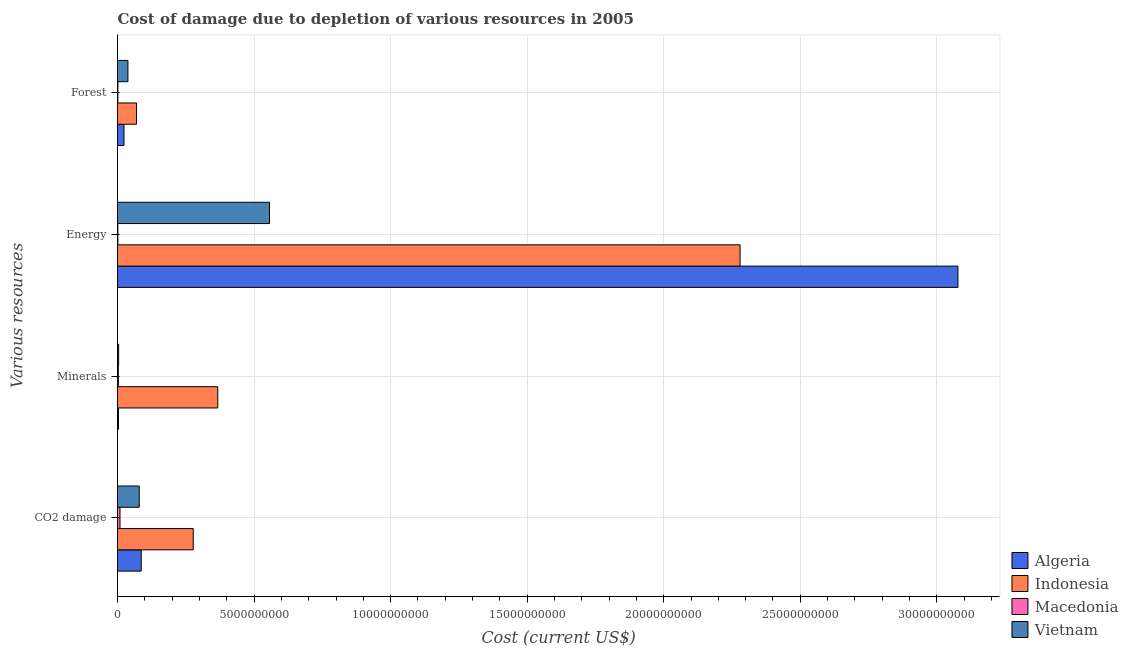How many different coloured bars are there?
Offer a very short reply. 4. How many bars are there on the 3rd tick from the top?
Your answer should be very brief. 4. What is the label of the 1st group of bars from the top?
Your response must be concise. Forest. What is the cost of damage due to depletion of coal in Macedonia?
Keep it short and to the point. 9.14e+07. Across all countries, what is the maximum cost of damage due to depletion of minerals?
Keep it short and to the point. 3.67e+09. Across all countries, what is the minimum cost of damage due to depletion of minerals?
Make the answer very short. 3.05e+07. In which country was the cost of damage due to depletion of energy maximum?
Make the answer very short. Algeria. In which country was the cost of damage due to depletion of forests minimum?
Keep it short and to the point. Macedonia. What is the total cost of damage due to depletion of forests in the graph?
Offer a very short reply. 1.33e+09. What is the difference between the cost of damage due to depletion of minerals in Macedonia and that in Vietnam?
Provide a succinct answer. -1.06e+07. What is the difference between the cost of damage due to depletion of coal in Algeria and the cost of damage due to depletion of energy in Vietnam?
Offer a terse response. -4.70e+09. What is the average cost of damage due to depletion of forests per country?
Ensure brevity in your answer.  3.32e+08. What is the difference between the cost of damage due to depletion of forests and cost of damage due to depletion of coal in Algeria?
Make the answer very short. -6.31e+08. In how many countries, is the cost of damage due to depletion of minerals greater than 9000000000 US$?
Ensure brevity in your answer.  0. What is the ratio of the cost of damage due to depletion of energy in Indonesia to that in Algeria?
Provide a short and direct response. 0.74. What is the difference between the highest and the second highest cost of damage due to depletion of minerals?
Your response must be concise. 3.63e+09. What is the difference between the highest and the lowest cost of damage due to depletion of coal?
Your response must be concise. 2.68e+09. Is the sum of the cost of damage due to depletion of minerals in Macedonia and Algeria greater than the maximum cost of damage due to depletion of energy across all countries?
Your response must be concise. No. Is it the case that in every country, the sum of the cost of damage due to depletion of minerals and cost of damage due to depletion of forests is greater than the sum of cost of damage due to depletion of coal and cost of damage due to depletion of energy?
Offer a very short reply. No. What does the 2nd bar from the top in Energy represents?
Give a very brief answer. Macedonia. What does the 3rd bar from the bottom in Forest represents?
Your response must be concise. Macedonia. Is it the case that in every country, the sum of the cost of damage due to depletion of coal and cost of damage due to depletion of minerals is greater than the cost of damage due to depletion of energy?
Provide a short and direct response. No. Are all the bars in the graph horizontal?
Offer a terse response. Yes. How many countries are there in the graph?
Keep it short and to the point. 4. Are the values on the major ticks of X-axis written in scientific E-notation?
Ensure brevity in your answer.  No. Does the graph contain any zero values?
Offer a terse response. No. Does the graph contain grids?
Ensure brevity in your answer.  Yes. How are the legend labels stacked?
Your answer should be very brief. Vertical. What is the title of the graph?
Your response must be concise. Cost of damage due to depletion of various resources in 2005 . Does "Lesotho" appear as one of the legend labels in the graph?
Your answer should be very brief. No. What is the label or title of the X-axis?
Your answer should be compact. Cost (current US$). What is the label or title of the Y-axis?
Your answer should be compact. Various resources. What is the Cost (current US$) in Algeria in CO2 damage?
Make the answer very short. 8.68e+08. What is the Cost (current US$) in Indonesia in CO2 damage?
Keep it short and to the point. 2.77e+09. What is the Cost (current US$) of Macedonia in CO2 damage?
Provide a short and direct response. 9.14e+07. What is the Cost (current US$) of Vietnam in CO2 damage?
Provide a short and direct response. 7.96e+08. What is the Cost (current US$) of Algeria in Minerals?
Offer a terse response. 3.52e+07. What is the Cost (current US$) in Indonesia in Minerals?
Your response must be concise. 3.67e+09. What is the Cost (current US$) in Macedonia in Minerals?
Keep it short and to the point. 3.05e+07. What is the Cost (current US$) of Vietnam in Minerals?
Your response must be concise. 4.10e+07. What is the Cost (current US$) of Algeria in Energy?
Provide a succinct answer. 3.08e+1. What is the Cost (current US$) of Indonesia in Energy?
Make the answer very short. 2.28e+1. What is the Cost (current US$) of Macedonia in Energy?
Your response must be concise. 1.33e+07. What is the Cost (current US$) in Vietnam in Energy?
Make the answer very short. 5.57e+09. What is the Cost (current US$) of Algeria in Forest?
Give a very brief answer. 2.37e+08. What is the Cost (current US$) of Indonesia in Forest?
Ensure brevity in your answer.  6.95e+08. What is the Cost (current US$) of Macedonia in Forest?
Provide a succinct answer. 1.38e+07. What is the Cost (current US$) of Vietnam in Forest?
Provide a succinct answer. 3.81e+08. Across all Various resources, what is the maximum Cost (current US$) in Algeria?
Give a very brief answer. 3.08e+1. Across all Various resources, what is the maximum Cost (current US$) in Indonesia?
Give a very brief answer. 2.28e+1. Across all Various resources, what is the maximum Cost (current US$) of Macedonia?
Provide a succinct answer. 9.14e+07. Across all Various resources, what is the maximum Cost (current US$) in Vietnam?
Offer a very short reply. 5.57e+09. Across all Various resources, what is the minimum Cost (current US$) of Algeria?
Your response must be concise. 3.52e+07. Across all Various resources, what is the minimum Cost (current US$) of Indonesia?
Ensure brevity in your answer.  6.95e+08. Across all Various resources, what is the minimum Cost (current US$) of Macedonia?
Keep it short and to the point. 1.33e+07. Across all Various resources, what is the minimum Cost (current US$) of Vietnam?
Offer a very short reply. 4.10e+07. What is the total Cost (current US$) of Algeria in the graph?
Provide a short and direct response. 3.19e+1. What is the total Cost (current US$) of Indonesia in the graph?
Offer a very short reply. 2.99e+1. What is the total Cost (current US$) of Macedonia in the graph?
Your answer should be compact. 1.49e+08. What is the total Cost (current US$) in Vietnam in the graph?
Your response must be concise. 6.78e+09. What is the difference between the Cost (current US$) of Algeria in CO2 damage and that in Minerals?
Your response must be concise. 8.33e+08. What is the difference between the Cost (current US$) in Indonesia in CO2 damage and that in Minerals?
Offer a very short reply. -8.98e+08. What is the difference between the Cost (current US$) in Macedonia in CO2 damage and that in Minerals?
Give a very brief answer. 6.10e+07. What is the difference between the Cost (current US$) in Vietnam in CO2 damage and that in Minerals?
Keep it short and to the point. 7.54e+08. What is the difference between the Cost (current US$) of Algeria in CO2 damage and that in Energy?
Give a very brief answer. -2.99e+1. What is the difference between the Cost (current US$) of Indonesia in CO2 damage and that in Energy?
Ensure brevity in your answer.  -2.00e+1. What is the difference between the Cost (current US$) in Macedonia in CO2 damage and that in Energy?
Keep it short and to the point. 7.81e+07. What is the difference between the Cost (current US$) in Vietnam in CO2 damage and that in Energy?
Give a very brief answer. -4.77e+09. What is the difference between the Cost (current US$) of Algeria in CO2 damage and that in Forest?
Your response must be concise. 6.31e+08. What is the difference between the Cost (current US$) of Indonesia in CO2 damage and that in Forest?
Your response must be concise. 2.08e+09. What is the difference between the Cost (current US$) in Macedonia in CO2 damage and that in Forest?
Your answer should be compact. 7.76e+07. What is the difference between the Cost (current US$) in Vietnam in CO2 damage and that in Forest?
Provide a succinct answer. 4.14e+08. What is the difference between the Cost (current US$) in Algeria in Minerals and that in Energy?
Ensure brevity in your answer.  -3.07e+1. What is the difference between the Cost (current US$) of Indonesia in Minerals and that in Energy?
Give a very brief answer. -1.91e+1. What is the difference between the Cost (current US$) of Macedonia in Minerals and that in Energy?
Keep it short and to the point. 1.71e+07. What is the difference between the Cost (current US$) in Vietnam in Minerals and that in Energy?
Ensure brevity in your answer.  -5.52e+09. What is the difference between the Cost (current US$) in Algeria in Minerals and that in Forest?
Provide a short and direct response. -2.02e+08. What is the difference between the Cost (current US$) of Indonesia in Minerals and that in Forest?
Your response must be concise. 2.98e+09. What is the difference between the Cost (current US$) of Macedonia in Minerals and that in Forest?
Keep it short and to the point. 1.66e+07. What is the difference between the Cost (current US$) in Vietnam in Minerals and that in Forest?
Your response must be concise. -3.40e+08. What is the difference between the Cost (current US$) in Algeria in Energy and that in Forest?
Provide a short and direct response. 3.05e+1. What is the difference between the Cost (current US$) of Indonesia in Energy and that in Forest?
Offer a very short reply. 2.21e+1. What is the difference between the Cost (current US$) in Macedonia in Energy and that in Forest?
Ensure brevity in your answer.  -5.04e+05. What is the difference between the Cost (current US$) in Vietnam in Energy and that in Forest?
Offer a terse response. 5.18e+09. What is the difference between the Cost (current US$) of Algeria in CO2 damage and the Cost (current US$) of Indonesia in Minerals?
Your answer should be very brief. -2.80e+09. What is the difference between the Cost (current US$) in Algeria in CO2 damage and the Cost (current US$) in Macedonia in Minerals?
Give a very brief answer. 8.38e+08. What is the difference between the Cost (current US$) in Algeria in CO2 damage and the Cost (current US$) in Vietnam in Minerals?
Your response must be concise. 8.27e+08. What is the difference between the Cost (current US$) in Indonesia in CO2 damage and the Cost (current US$) in Macedonia in Minerals?
Offer a terse response. 2.74e+09. What is the difference between the Cost (current US$) in Indonesia in CO2 damage and the Cost (current US$) in Vietnam in Minerals?
Your response must be concise. 2.73e+09. What is the difference between the Cost (current US$) in Macedonia in CO2 damage and the Cost (current US$) in Vietnam in Minerals?
Give a very brief answer. 5.04e+07. What is the difference between the Cost (current US$) of Algeria in CO2 damage and the Cost (current US$) of Indonesia in Energy?
Provide a short and direct response. -2.19e+1. What is the difference between the Cost (current US$) in Algeria in CO2 damage and the Cost (current US$) in Macedonia in Energy?
Ensure brevity in your answer.  8.55e+08. What is the difference between the Cost (current US$) in Algeria in CO2 damage and the Cost (current US$) in Vietnam in Energy?
Provide a short and direct response. -4.70e+09. What is the difference between the Cost (current US$) in Indonesia in CO2 damage and the Cost (current US$) in Macedonia in Energy?
Make the answer very short. 2.76e+09. What is the difference between the Cost (current US$) in Indonesia in CO2 damage and the Cost (current US$) in Vietnam in Energy?
Your answer should be very brief. -2.79e+09. What is the difference between the Cost (current US$) in Macedonia in CO2 damage and the Cost (current US$) in Vietnam in Energy?
Give a very brief answer. -5.47e+09. What is the difference between the Cost (current US$) of Algeria in CO2 damage and the Cost (current US$) of Indonesia in Forest?
Your response must be concise. 1.73e+08. What is the difference between the Cost (current US$) of Algeria in CO2 damage and the Cost (current US$) of Macedonia in Forest?
Your response must be concise. 8.55e+08. What is the difference between the Cost (current US$) of Algeria in CO2 damage and the Cost (current US$) of Vietnam in Forest?
Your answer should be very brief. 4.87e+08. What is the difference between the Cost (current US$) of Indonesia in CO2 damage and the Cost (current US$) of Macedonia in Forest?
Ensure brevity in your answer.  2.76e+09. What is the difference between the Cost (current US$) of Indonesia in CO2 damage and the Cost (current US$) of Vietnam in Forest?
Offer a very short reply. 2.39e+09. What is the difference between the Cost (current US$) of Macedonia in CO2 damage and the Cost (current US$) of Vietnam in Forest?
Your answer should be very brief. -2.90e+08. What is the difference between the Cost (current US$) in Algeria in Minerals and the Cost (current US$) in Indonesia in Energy?
Your answer should be very brief. -2.28e+1. What is the difference between the Cost (current US$) in Algeria in Minerals and the Cost (current US$) in Macedonia in Energy?
Make the answer very short. 2.19e+07. What is the difference between the Cost (current US$) in Algeria in Minerals and the Cost (current US$) in Vietnam in Energy?
Give a very brief answer. -5.53e+09. What is the difference between the Cost (current US$) in Indonesia in Minerals and the Cost (current US$) in Macedonia in Energy?
Ensure brevity in your answer.  3.66e+09. What is the difference between the Cost (current US$) in Indonesia in Minerals and the Cost (current US$) in Vietnam in Energy?
Your answer should be compact. -1.89e+09. What is the difference between the Cost (current US$) of Macedonia in Minerals and the Cost (current US$) of Vietnam in Energy?
Provide a succinct answer. -5.53e+09. What is the difference between the Cost (current US$) in Algeria in Minerals and the Cost (current US$) in Indonesia in Forest?
Provide a succinct answer. -6.60e+08. What is the difference between the Cost (current US$) in Algeria in Minerals and the Cost (current US$) in Macedonia in Forest?
Your answer should be very brief. 2.13e+07. What is the difference between the Cost (current US$) of Algeria in Minerals and the Cost (current US$) of Vietnam in Forest?
Your answer should be very brief. -3.46e+08. What is the difference between the Cost (current US$) in Indonesia in Minerals and the Cost (current US$) in Macedonia in Forest?
Offer a very short reply. 3.66e+09. What is the difference between the Cost (current US$) of Indonesia in Minerals and the Cost (current US$) of Vietnam in Forest?
Ensure brevity in your answer.  3.29e+09. What is the difference between the Cost (current US$) in Macedonia in Minerals and the Cost (current US$) in Vietnam in Forest?
Keep it short and to the point. -3.51e+08. What is the difference between the Cost (current US$) of Algeria in Energy and the Cost (current US$) of Indonesia in Forest?
Give a very brief answer. 3.01e+1. What is the difference between the Cost (current US$) of Algeria in Energy and the Cost (current US$) of Macedonia in Forest?
Give a very brief answer. 3.08e+1. What is the difference between the Cost (current US$) of Algeria in Energy and the Cost (current US$) of Vietnam in Forest?
Your response must be concise. 3.04e+1. What is the difference between the Cost (current US$) of Indonesia in Energy and the Cost (current US$) of Macedonia in Forest?
Give a very brief answer. 2.28e+1. What is the difference between the Cost (current US$) of Indonesia in Energy and the Cost (current US$) of Vietnam in Forest?
Provide a succinct answer. 2.24e+1. What is the difference between the Cost (current US$) of Macedonia in Energy and the Cost (current US$) of Vietnam in Forest?
Offer a terse response. -3.68e+08. What is the average Cost (current US$) in Algeria per Various resources?
Give a very brief answer. 7.98e+09. What is the average Cost (current US$) in Indonesia per Various resources?
Offer a very short reply. 7.48e+09. What is the average Cost (current US$) of Macedonia per Various resources?
Offer a very short reply. 3.73e+07. What is the average Cost (current US$) of Vietnam per Various resources?
Provide a short and direct response. 1.70e+09. What is the difference between the Cost (current US$) of Algeria and Cost (current US$) of Indonesia in CO2 damage?
Make the answer very short. -1.90e+09. What is the difference between the Cost (current US$) in Algeria and Cost (current US$) in Macedonia in CO2 damage?
Your response must be concise. 7.77e+08. What is the difference between the Cost (current US$) in Algeria and Cost (current US$) in Vietnam in CO2 damage?
Your response must be concise. 7.28e+07. What is the difference between the Cost (current US$) of Indonesia and Cost (current US$) of Macedonia in CO2 damage?
Provide a short and direct response. 2.68e+09. What is the difference between the Cost (current US$) in Indonesia and Cost (current US$) in Vietnam in CO2 damage?
Ensure brevity in your answer.  1.98e+09. What is the difference between the Cost (current US$) of Macedonia and Cost (current US$) of Vietnam in CO2 damage?
Keep it short and to the point. -7.04e+08. What is the difference between the Cost (current US$) in Algeria and Cost (current US$) in Indonesia in Minerals?
Your response must be concise. -3.64e+09. What is the difference between the Cost (current US$) of Algeria and Cost (current US$) of Macedonia in Minerals?
Your response must be concise. 4.71e+06. What is the difference between the Cost (current US$) of Algeria and Cost (current US$) of Vietnam in Minerals?
Keep it short and to the point. -5.87e+06. What is the difference between the Cost (current US$) of Indonesia and Cost (current US$) of Macedonia in Minerals?
Make the answer very short. 3.64e+09. What is the difference between the Cost (current US$) in Indonesia and Cost (current US$) in Vietnam in Minerals?
Your response must be concise. 3.63e+09. What is the difference between the Cost (current US$) of Macedonia and Cost (current US$) of Vietnam in Minerals?
Offer a terse response. -1.06e+07. What is the difference between the Cost (current US$) of Algeria and Cost (current US$) of Indonesia in Energy?
Your answer should be very brief. 7.98e+09. What is the difference between the Cost (current US$) in Algeria and Cost (current US$) in Macedonia in Energy?
Ensure brevity in your answer.  3.08e+1. What is the difference between the Cost (current US$) of Algeria and Cost (current US$) of Vietnam in Energy?
Your answer should be compact. 2.52e+1. What is the difference between the Cost (current US$) of Indonesia and Cost (current US$) of Macedonia in Energy?
Keep it short and to the point. 2.28e+1. What is the difference between the Cost (current US$) in Indonesia and Cost (current US$) in Vietnam in Energy?
Provide a short and direct response. 1.72e+1. What is the difference between the Cost (current US$) in Macedonia and Cost (current US$) in Vietnam in Energy?
Offer a terse response. -5.55e+09. What is the difference between the Cost (current US$) of Algeria and Cost (current US$) of Indonesia in Forest?
Keep it short and to the point. -4.58e+08. What is the difference between the Cost (current US$) in Algeria and Cost (current US$) in Macedonia in Forest?
Ensure brevity in your answer.  2.23e+08. What is the difference between the Cost (current US$) in Algeria and Cost (current US$) in Vietnam in Forest?
Ensure brevity in your answer.  -1.44e+08. What is the difference between the Cost (current US$) of Indonesia and Cost (current US$) of Macedonia in Forest?
Keep it short and to the point. 6.81e+08. What is the difference between the Cost (current US$) in Indonesia and Cost (current US$) in Vietnam in Forest?
Offer a very short reply. 3.14e+08. What is the difference between the Cost (current US$) in Macedonia and Cost (current US$) in Vietnam in Forest?
Your response must be concise. -3.68e+08. What is the ratio of the Cost (current US$) of Algeria in CO2 damage to that in Minerals?
Provide a succinct answer. 24.69. What is the ratio of the Cost (current US$) of Indonesia in CO2 damage to that in Minerals?
Ensure brevity in your answer.  0.76. What is the ratio of the Cost (current US$) in Macedonia in CO2 damage to that in Minerals?
Give a very brief answer. 3. What is the ratio of the Cost (current US$) in Vietnam in CO2 damage to that in Minerals?
Ensure brevity in your answer.  19.38. What is the ratio of the Cost (current US$) of Algeria in CO2 damage to that in Energy?
Make the answer very short. 0.03. What is the ratio of the Cost (current US$) in Indonesia in CO2 damage to that in Energy?
Provide a succinct answer. 0.12. What is the ratio of the Cost (current US$) in Macedonia in CO2 damage to that in Energy?
Offer a terse response. 6.87. What is the ratio of the Cost (current US$) in Vietnam in CO2 damage to that in Energy?
Make the answer very short. 0.14. What is the ratio of the Cost (current US$) in Algeria in CO2 damage to that in Forest?
Give a very brief answer. 3.66. What is the ratio of the Cost (current US$) in Indonesia in CO2 damage to that in Forest?
Give a very brief answer. 3.99. What is the ratio of the Cost (current US$) in Macedonia in CO2 damage to that in Forest?
Offer a very short reply. 6.62. What is the ratio of the Cost (current US$) of Vietnam in CO2 damage to that in Forest?
Offer a terse response. 2.09. What is the ratio of the Cost (current US$) of Algeria in Minerals to that in Energy?
Provide a short and direct response. 0. What is the ratio of the Cost (current US$) in Indonesia in Minerals to that in Energy?
Keep it short and to the point. 0.16. What is the ratio of the Cost (current US$) of Macedonia in Minerals to that in Energy?
Give a very brief answer. 2.29. What is the ratio of the Cost (current US$) of Vietnam in Minerals to that in Energy?
Offer a terse response. 0.01. What is the ratio of the Cost (current US$) in Algeria in Minerals to that in Forest?
Provide a succinct answer. 0.15. What is the ratio of the Cost (current US$) of Indonesia in Minerals to that in Forest?
Offer a very short reply. 5.28. What is the ratio of the Cost (current US$) of Macedonia in Minerals to that in Forest?
Offer a very short reply. 2.2. What is the ratio of the Cost (current US$) in Vietnam in Minerals to that in Forest?
Make the answer very short. 0.11. What is the ratio of the Cost (current US$) in Algeria in Energy to that in Forest?
Ensure brevity in your answer.  129.7. What is the ratio of the Cost (current US$) of Indonesia in Energy to that in Forest?
Offer a very short reply. 32.79. What is the ratio of the Cost (current US$) in Macedonia in Energy to that in Forest?
Offer a very short reply. 0.96. What is the ratio of the Cost (current US$) in Vietnam in Energy to that in Forest?
Keep it short and to the point. 14.59. What is the difference between the highest and the second highest Cost (current US$) in Algeria?
Make the answer very short. 2.99e+1. What is the difference between the highest and the second highest Cost (current US$) of Indonesia?
Give a very brief answer. 1.91e+1. What is the difference between the highest and the second highest Cost (current US$) in Macedonia?
Offer a terse response. 6.10e+07. What is the difference between the highest and the second highest Cost (current US$) of Vietnam?
Provide a succinct answer. 4.77e+09. What is the difference between the highest and the lowest Cost (current US$) of Algeria?
Your response must be concise. 3.07e+1. What is the difference between the highest and the lowest Cost (current US$) in Indonesia?
Provide a succinct answer. 2.21e+1. What is the difference between the highest and the lowest Cost (current US$) in Macedonia?
Offer a terse response. 7.81e+07. What is the difference between the highest and the lowest Cost (current US$) of Vietnam?
Your answer should be compact. 5.52e+09. 